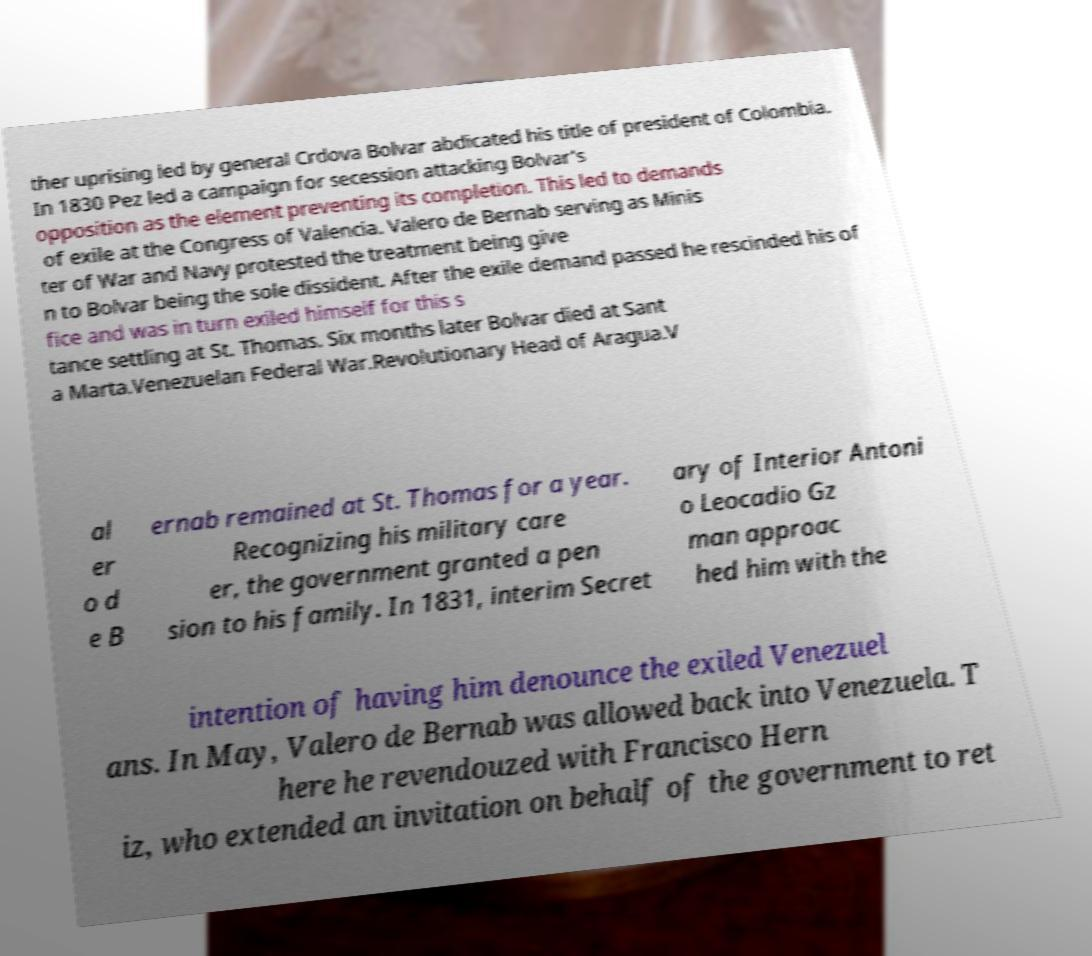Please read and relay the text visible in this image. What does it say? ther uprising led by general Crdova Bolvar abdicated his title of president of Colombia. In 1830 Pez led a campaign for secession attacking Bolvar's opposition as the element preventing its completion. This led to demands of exile at the Congress of Valencia. Valero de Bernab serving as Minis ter of War and Navy protested the treatment being give n to Bolvar being the sole dissident. After the exile demand passed he rescinded his of fice and was in turn exiled himself for this s tance settling at St. Thomas. Six months later Bolvar died at Sant a Marta.Venezuelan Federal War.Revolutionary Head of Aragua.V al er o d e B ernab remained at St. Thomas for a year. Recognizing his military care er, the government granted a pen sion to his family. In 1831, interim Secret ary of Interior Antoni o Leocadio Gz man approac hed him with the intention of having him denounce the exiled Venezuel ans. In May, Valero de Bernab was allowed back into Venezuela. T here he revendouzed with Francisco Hern iz, who extended an invitation on behalf of the government to ret 